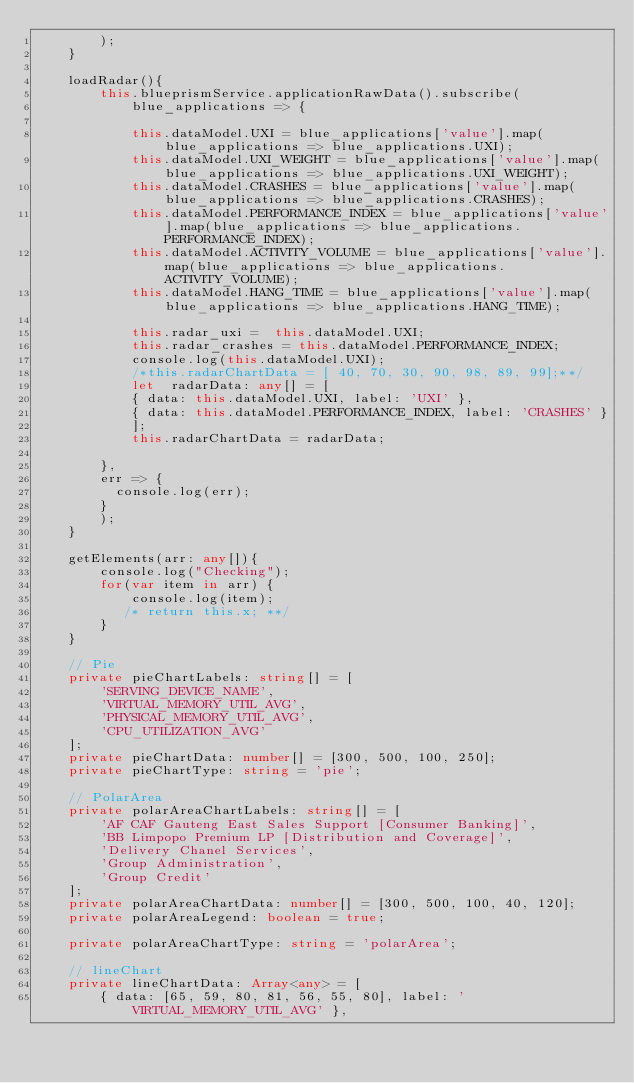<code> <loc_0><loc_0><loc_500><loc_500><_TypeScript_>        );  
    }

    loadRadar(){
        this.blueprismService.applicationRawData().subscribe(
            blue_applications => {

            this.dataModel.UXI = blue_applications['value'].map(blue_applications => blue_applications.UXI);
            this.dataModel.UXI_WEIGHT = blue_applications['value'].map(blue_applications => blue_applications.UXI_WEIGHT);
            this.dataModel.CRASHES = blue_applications['value'].map(blue_applications => blue_applications.CRASHES);
            this.dataModel.PERFORMANCE_INDEX = blue_applications['value'].map(blue_applications => blue_applications.PERFORMANCE_INDEX);
            this.dataModel.ACTIVITY_VOLUME = blue_applications['value'].map(blue_applications => blue_applications.ACTIVITY_VOLUME);
            this.dataModel.HANG_TIME = blue_applications['value'].map(blue_applications => blue_applications.HANG_TIME);
               
            this.radar_uxi =  this.dataModel.UXI; 
            this.radar_crashes = this.dataModel.PERFORMANCE_INDEX;
            console.log(this.dataModel.UXI);
            /*this.radarChartData = [ 40, 70, 30, 90, 98, 89, 99];**/
            let  radarData: any[] = [
            { data: this.dataModel.UXI, label: 'UXI' },   
            { data: this.dataModel.PERFORMANCE_INDEX, label: 'CRASHES' } 
            ];
            this.radarChartData = radarData;
            
        },
        err => {
          console.log(err);
        }
        ); 
    }

    getElements(arr: any[]){
        console.log("Checking");
        for(var item in arr) {
            console.log(item);
           /* return this.x; **/
        }
    }
    
    // Pie
    private pieChartLabels: string[] = [
        'SERVING_DEVICE_NAME',
        'VIRTUAL_MEMORY_UTIL_AVG',
        'PHYSICAL_MEMORY_UTIL_AVG',
        'CPU_UTILIZATION_AVG'
    ];
    private pieChartData: number[] = [300, 500, 100, 250];
    private pieChartType: string = 'pie';

    // PolarArea
    private polarAreaChartLabels: string[] = [
        'AF CAF Gauteng East Sales Support [Consumer Banking]',
        'BB Limpopo Premium LP [Distribution and Coverage]',
        'Delivery Chanel Services',
        'Group Administration',
        'Group Credit'
    ];
    private polarAreaChartData: number[] = [300, 500, 100, 40, 120];
    private polarAreaLegend: boolean = true;

    private polarAreaChartType: string = 'polarArea';

    // lineChart
    private lineChartData: Array<any> = [
        { data: [65, 59, 80, 81, 56, 55, 80], label: 'VIRTUAL_MEMORY_UTIL_AVG' },</code> 